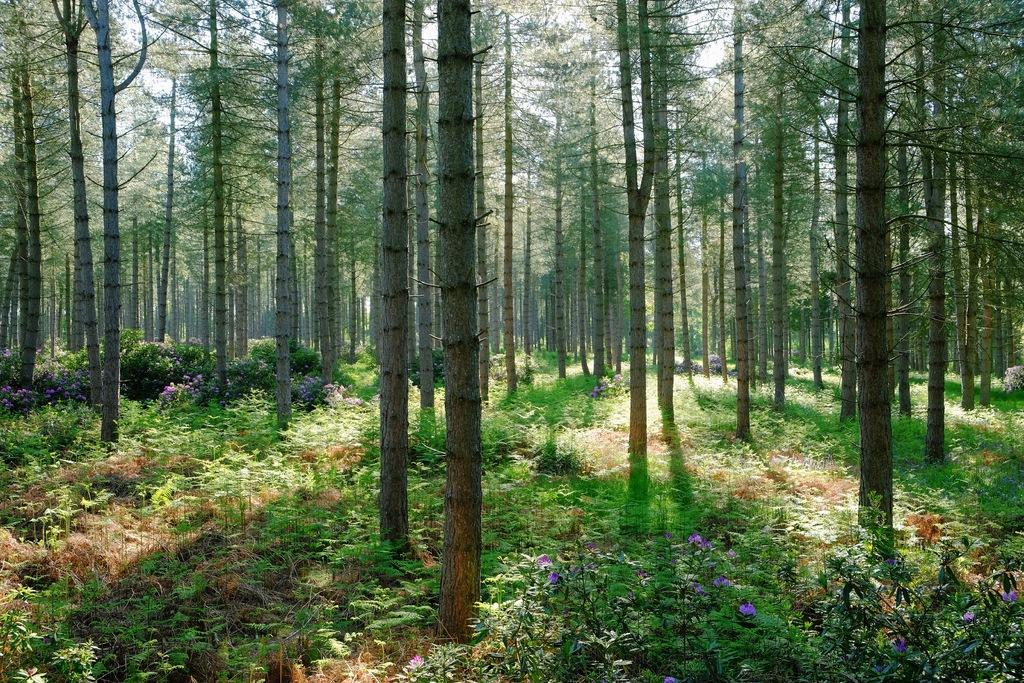What type of vegetation is present in the image? There are trees and plants with branches, leaves, flowers, and leaves in the image. Can you describe the trees in the image? The trees in the image have branches and leaves. What can be observed about the plants in the image? The plants in the image have flowers and leaves. What type of drain is visible in the image? There is no drain present in the image; it features trees and plants with branches, leaves, flowers, and leaves. How would you describe the taste of the chair in the image? There is no chair present in the image, and therefore its taste cannot be described. 